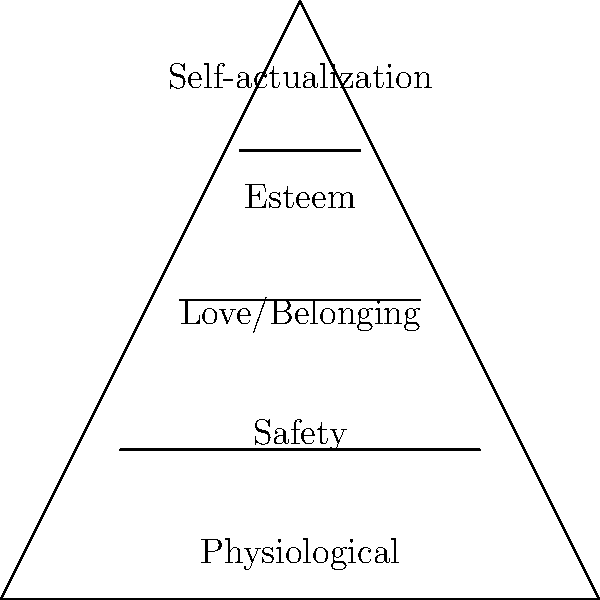In social work practice, Maslow's Hierarchy of Needs is often used to understand client needs. Based on the pyramid diagram, which need should be addressed first when working with a homeless teenager? To answer this question, we need to understand Maslow's Hierarchy of Needs and its application in social work:

1. The pyramid diagram represents Maslow's Hierarchy of Needs, with the most basic needs at the bottom and more complex needs at the top.

2. The levels of the pyramid, from bottom to top, are:
   a) Physiological needs
   b) Safety needs
   c) Love and belonging needs
   d) Esteem needs
   e) Self-actualization needs

3. In social work practice, it's essential to address the most basic needs first before moving up the hierarchy.

4. For a homeless teenager, the most pressing concern would be their physiological needs, which include food, water, shelter, and warmth.

5. Without these basic needs met, it would be challenging for the teenager to focus on higher-level needs such as safety, relationships, or personal growth.

6. As a future social worker, your first priority would be to ensure the teenager has access to food, shelter, and other basic necessities before addressing other concerns.

Therefore, based on Maslow's Hierarchy of Needs, the physiological needs at the bottom of the pyramid should be addressed first when working with a homeless teenager.
Answer: Physiological needs 